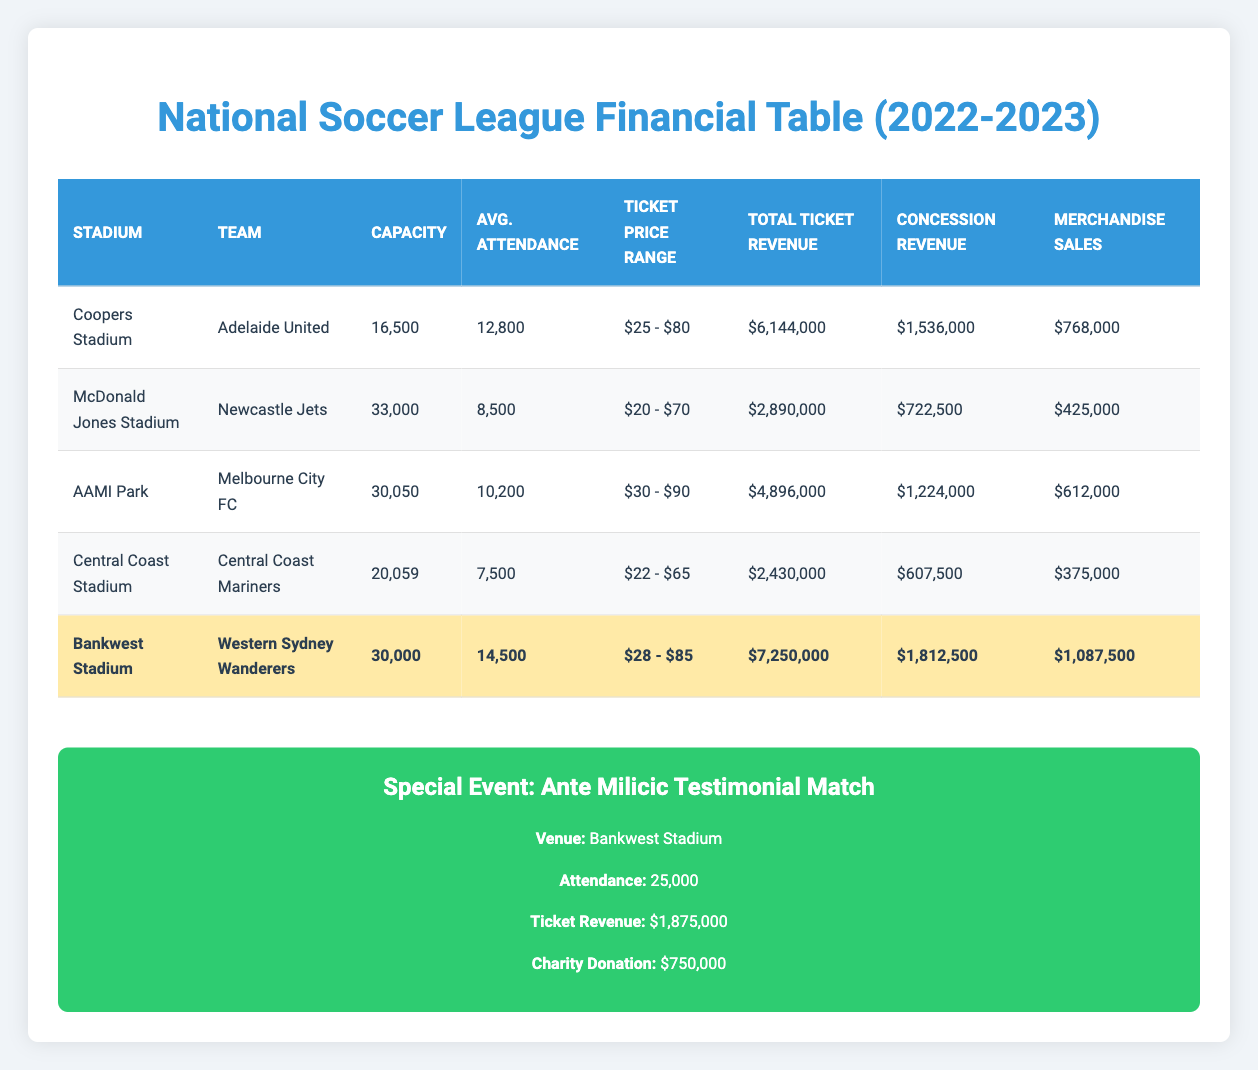What is the total ticket revenue for Bankwest Stadium? The ticket revenue for Bankwest Stadium is listed directly in the table under "Total Ticket Revenue," which reads $7,250,000.
Answer: $7,250,000 Which team plays at Central Coast Stadium? The team playing at Central Coast Stadium is provided in the "Team" column of the table, listed as Central Coast Mariners.
Answer: Central Coast Mariners What is the average attendance across all stadiums? To find the average attendance, I will sum the average attendance values for each stadium: (12800 + 8500 + 10200 + 7500 + 14500) = 52500, then divide by the number of stadiums (5): 52500 / 5 = 10500.
Answer: 10,500 Is the total ticket revenue for McDonald Jones Stadium greater than $3 million? The total ticket revenue for McDonald Jones Stadium is $2,890,000, which is less than $3 million. Therefore, the answer is no.
Answer: No Which stadium has the highest concession revenue? To determine which stadium has the highest concession revenue, I will compare the values listed under "Concession Revenue" for all stadiums: Bankwest Stadium has $1,812,500, Coopers Stadium has $1,536,000, AAMI Park has $1,224,000, McDonald Jones Stadium has $722,500, and Central Coast Stadium has $607,500. The highest value is $1,812,500 from Bankwest Stadium.
Answer: Bankwest Stadium What is the total merchandise sales for all stadiums combined? To find total merchandise sales, I will add the figures together: $768,000 + $425,000 + $612,000 + $375,000 + $1,087,500 = $3,267,500. This gives the total merchandise sales.
Answer: $3,267,500 Does AAMI Park have a higher capacity than Coopers Stadium? The capacity of AAMI Park is 30,050, while Coopers Stadium has a capacity of 16,500. Since 30,050 is greater than 16,500, the answer is yes.
Answer: Yes What is the ticket price range for Newcastle Jets? The ticket price range for Newcastle Jets is found in the "Ticket Price Range" column, which states it is $20 - $70.
Answer: $20 - $70 How much was the charity donation for the Ante Milicic Testimonial Match? The charity donation for the Ante Milicic Testimonial Match is provided under "Charity Donation" in the special events section, listed as $750,000.
Answer: $750,000 